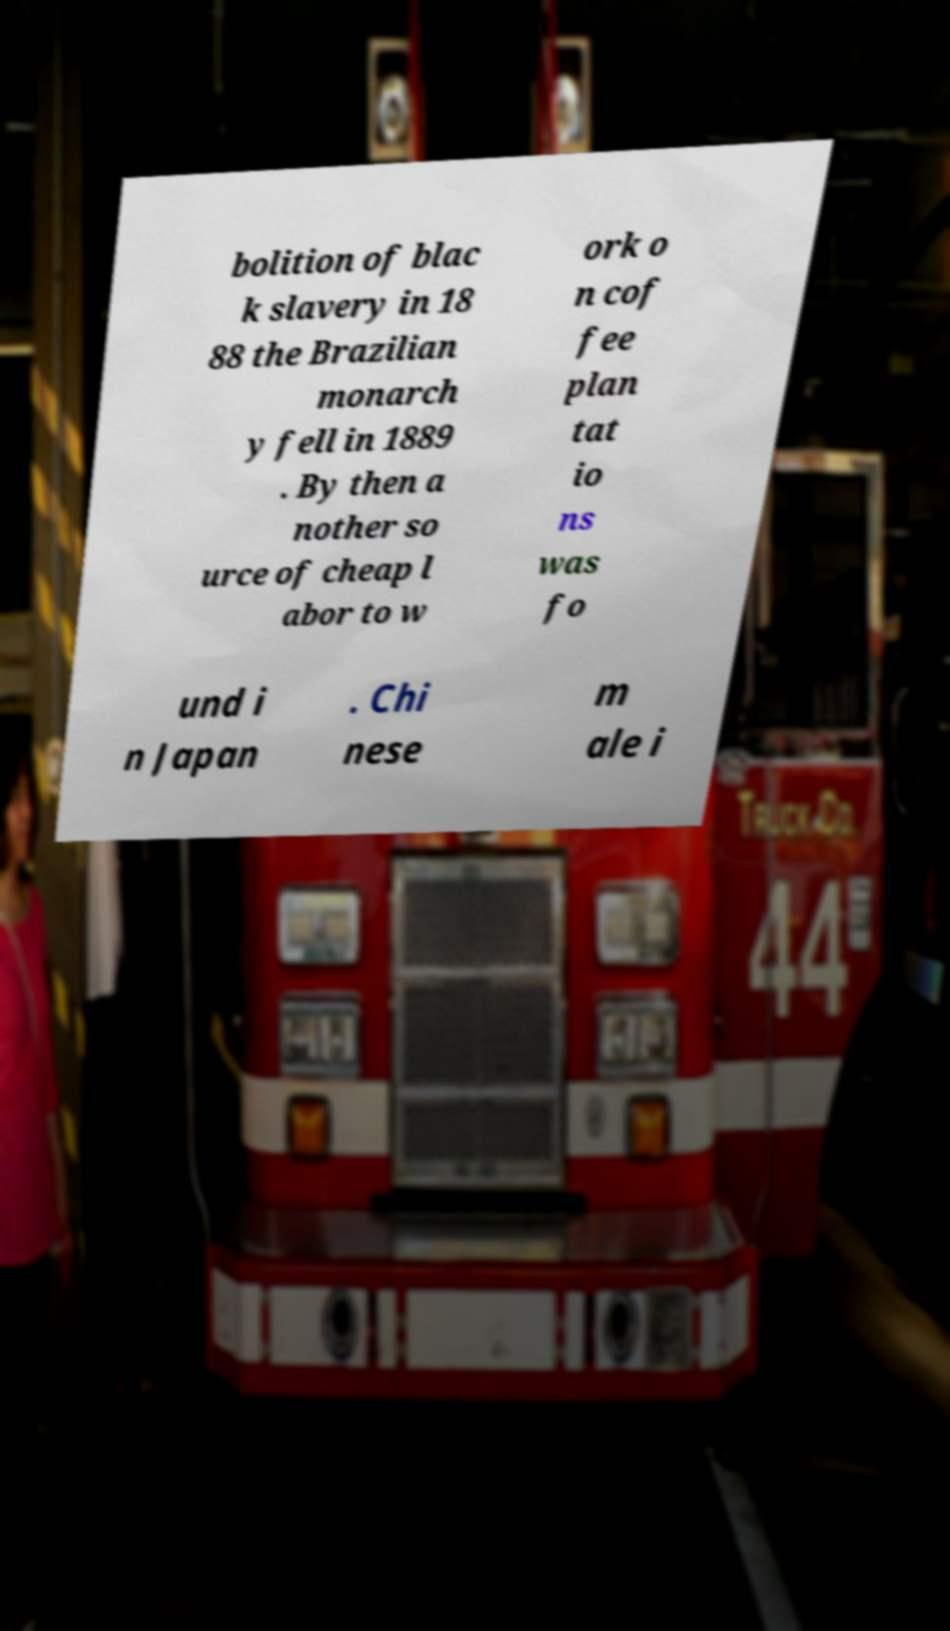Please read and relay the text visible in this image. What does it say? bolition of blac k slavery in 18 88 the Brazilian monarch y fell in 1889 . By then a nother so urce of cheap l abor to w ork o n cof fee plan tat io ns was fo und i n Japan . Chi nese m ale i 